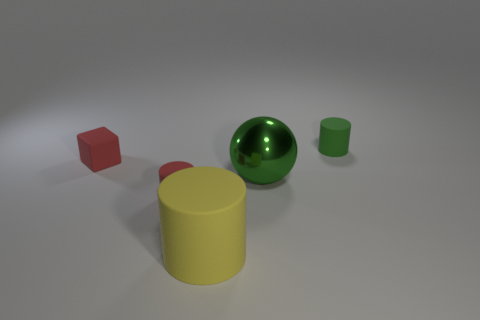Are there any other things that are the same material as the big ball?
Your response must be concise. No. Do the small cylinder left of the tiny green cylinder and the tiny red object that is behind the green metallic object have the same material?
Your answer should be compact. Yes. Are there fewer large green metal spheres on the left side of the red cube than green objects?
Your response must be concise. Yes. There is a red object that is to the right of the cube; what number of big green objects are right of it?
Give a very brief answer. 1. There is a cylinder that is behind the large yellow matte cylinder and to the left of the small green object; what is its size?
Offer a terse response. Small. Is the material of the red cube the same as the tiny red object that is in front of the large green sphere?
Your answer should be very brief. Yes. Are there fewer green balls in front of the yellow matte object than big yellow things that are in front of the green rubber cylinder?
Give a very brief answer. Yes. What is the cylinder behind the red matte block made of?
Offer a terse response. Rubber. There is a object that is behind the green metallic ball and right of the large yellow cylinder; what color is it?
Ensure brevity in your answer.  Green. What number of other objects are the same color as the large rubber cylinder?
Give a very brief answer. 0. 